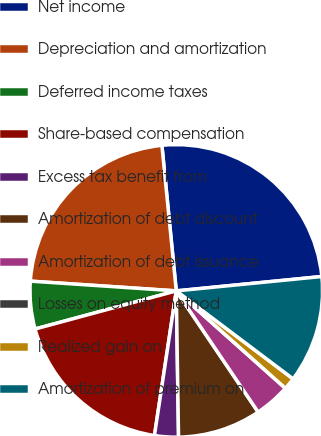Convert chart to OTSL. <chart><loc_0><loc_0><loc_500><loc_500><pie_chart><fcel>Net income<fcel>Depreciation and amortization<fcel>Deferred income taxes<fcel>Share-based compensation<fcel>Excess tax benefit from<fcel>Amortization of debt discount<fcel>Amortization of debt issuance<fcel>Losses on equity method<fcel>Realized gain on<fcel>Amortization of premium on<nl><fcel>25.0%<fcel>22.37%<fcel>5.26%<fcel>18.42%<fcel>2.63%<fcel>9.21%<fcel>3.95%<fcel>0.0%<fcel>1.32%<fcel>11.84%<nl></chart> 